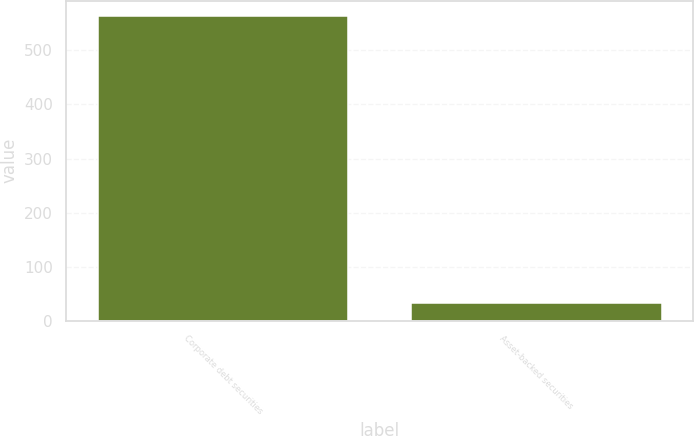<chart> <loc_0><loc_0><loc_500><loc_500><bar_chart><fcel>Corporate debt securities<fcel>Asset-backed securities<nl><fcel>564<fcel>32<nl></chart> 